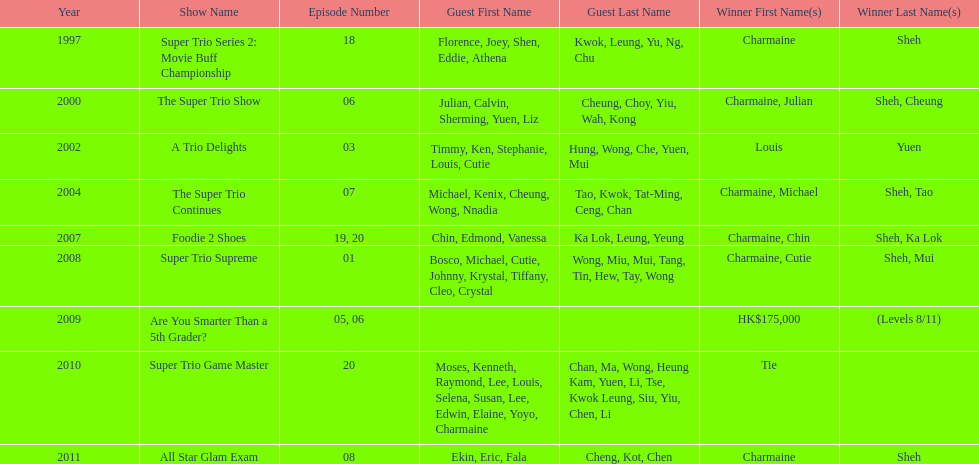Could you parse the entire table as a dict? {'header': ['Year', 'Show Name', 'Episode Number', 'Guest First Name', 'Guest Last Name', 'Winner First Name(s)', 'Winner Last Name(s)'], 'rows': [['1997', 'Super Trio Series 2: Movie Buff Championship', '18', 'Florence, Joey, Shen, Eddie, Athena', 'Kwok, Leung, Yu, Ng, Chu', 'Charmaine', 'Sheh'], ['2000', 'The Super Trio Show', '06', 'Julian, Calvin, Sherming, Yuen, Liz', 'Cheung, Choy, Yiu, Wah, Kong', 'Charmaine, Julian', 'Sheh, Cheung'], ['2002', 'A Trio Delights', '03', 'Timmy, Ken, Stephanie, Louis, Cutie', 'Hung, Wong, Che, Yuen, Mui', 'Louis', 'Yuen'], ['2004', 'The Super Trio Continues', '07', 'Michael, Kenix, Cheung, Wong, Nnadia', 'Tao, Kwok, Tat-Ming, Ceng, Chan', 'Charmaine, Michael', 'Sheh, Tao'], ['2007', 'Foodie 2 Shoes', '19, 20', 'Chin, Edmond, Vanessa', 'Ka Lok, Leung, Yeung', 'Charmaine, Chin', 'Sheh, Ka Lok'], ['2008', 'Super Trio Supreme', '01', 'Bosco, Michael, Cutie, Johnny, Krystal, Tiffany, Cleo, Crystal', 'Wong, Miu, Mui, Tang, Tin, Hew, Tay, Wong', 'Charmaine, Cutie', 'Sheh, Mui'], ['2009', 'Are You Smarter Than a 5th Grader?', '05, 06', '', '', 'HK$175,000', '(Levels 8/11)'], ['2010', 'Super Trio Game Master', '20', 'Moses, Kenneth, Raymond, Lee, Louis, Selena, Susan, Lee, Edwin, Elaine, Yoyo, Charmaine', 'Chan, Ma, Wong, Heung Kam, Yuen, Li, Tse, Kwok Leung, Siu, Yiu, Chen, Li', 'Tie', ''], ['2011', 'All Star Glam Exam', '08', 'Ekin, Eric, Fala', 'Cheng, Kot, Chen', 'Charmaine', 'Sheh']]} What is the number of other guests in the 2002 show "a trio delights"? 5. 